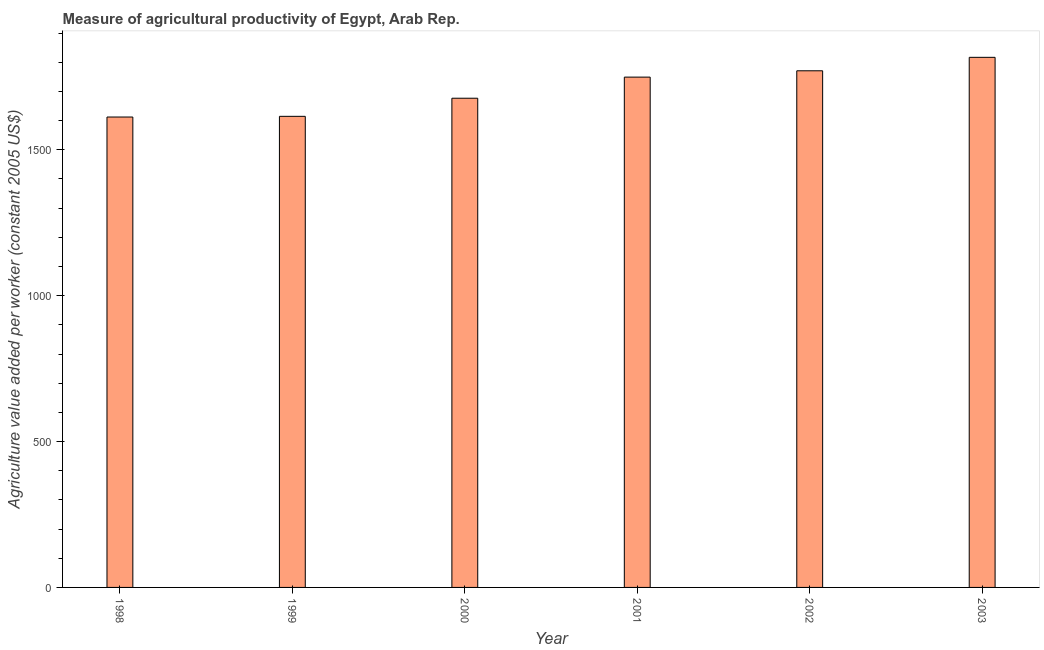What is the title of the graph?
Provide a short and direct response. Measure of agricultural productivity of Egypt, Arab Rep. What is the label or title of the X-axis?
Provide a succinct answer. Year. What is the label or title of the Y-axis?
Ensure brevity in your answer.  Agriculture value added per worker (constant 2005 US$). What is the agriculture value added per worker in 2000?
Make the answer very short. 1676.86. Across all years, what is the maximum agriculture value added per worker?
Your answer should be very brief. 1817.06. Across all years, what is the minimum agriculture value added per worker?
Your answer should be very brief. 1612.44. In which year was the agriculture value added per worker minimum?
Provide a short and direct response. 1998. What is the sum of the agriculture value added per worker?
Make the answer very short. 1.02e+04. What is the difference between the agriculture value added per worker in 2000 and 2002?
Provide a short and direct response. -94.06. What is the average agriculture value added per worker per year?
Your answer should be very brief. 1706.89. What is the median agriculture value added per worker?
Give a very brief answer. 1713.05. In how many years, is the agriculture value added per worker greater than 200 US$?
Provide a succinct answer. 6. Is the agriculture value added per worker in 2000 less than that in 2002?
Provide a succinct answer. Yes. Is the difference between the agriculture value added per worker in 1999 and 2002 greater than the difference between any two years?
Offer a terse response. No. What is the difference between the highest and the second highest agriculture value added per worker?
Your response must be concise. 46.13. Is the sum of the agriculture value added per worker in 1998 and 2001 greater than the maximum agriculture value added per worker across all years?
Keep it short and to the point. Yes. What is the difference between the highest and the lowest agriculture value added per worker?
Your answer should be compact. 204.62. In how many years, is the agriculture value added per worker greater than the average agriculture value added per worker taken over all years?
Your answer should be compact. 3. How many bars are there?
Your response must be concise. 6. What is the difference between two consecutive major ticks on the Y-axis?
Give a very brief answer. 500. Are the values on the major ticks of Y-axis written in scientific E-notation?
Offer a terse response. No. What is the Agriculture value added per worker (constant 2005 US$) of 1998?
Give a very brief answer. 1612.44. What is the Agriculture value added per worker (constant 2005 US$) of 1999?
Your answer should be very brief. 1614.8. What is the Agriculture value added per worker (constant 2005 US$) of 2000?
Provide a short and direct response. 1676.86. What is the Agriculture value added per worker (constant 2005 US$) of 2001?
Offer a very short reply. 1749.25. What is the Agriculture value added per worker (constant 2005 US$) in 2002?
Offer a very short reply. 1770.92. What is the Agriculture value added per worker (constant 2005 US$) of 2003?
Offer a very short reply. 1817.06. What is the difference between the Agriculture value added per worker (constant 2005 US$) in 1998 and 1999?
Ensure brevity in your answer.  -2.37. What is the difference between the Agriculture value added per worker (constant 2005 US$) in 1998 and 2000?
Your answer should be very brief. -64.42. What is the difference between the Agriculture value added per worker (constant 2005 US$) in 1998 and 2001?
Offer a very short reply. -136.81. What is the difference between the Agriculture value added per worker (constant 2005 US$) in 1998 and 2002?
Provide a short and direct response. -158.49. What is the difference between the Agriculture value added per worker (constant 2005 US$) in 1998 and 2003?
Your answer should be very brief. -204.62. What is the difference between the Agriculture value added per worker (constant 2005 US$) in 1999 and 2000?
Provide a succinct answer. -62.05. What is the difference between the Agriculture value added per worker (constant 2005 US$) in 1999 and 2001?
Offer a very short reply. -134.44. What is the difference between the Agriculture value added per worker (constant 2005 US$) in 1999 and 2002?
Offer a very short reply. -156.12. What is the difference between the Agriculture value added per worker (constant 2005 US$) in 1999 and 2003?
Ensure brevity in your answer.  -202.25. What is the difference between the Agriculture value added per worker (constant 2005 US$) in 2000 and 2001?
Provide a short and direct response. -72.39. What is the difference between the Agriculture value added per worker (constant 2005 US$) in 2000 and 2002?
Provide a succinct answer. -94.06. What is the difference between the Agriculture value added per worker (constant 2005 US$) in 2000 and 2003?
Your response must be concise. -140.2. What is the difference between the Agriculture value added per worker (constant 2005 US$) in 2001 and 2002?
Your answer should be very brief. -21.67. What is the difference between the Agriculture value added per worker (constant 2005 US$) in 2001 and 2003?
Offer a very short reply. -67.81. What is the difference between the Agriculture value added per worker (constant 2005 US$) in 2002 and 2003?
Your response must be concise. -46.13. What is the ratio of the Agriculture value added per worker (constant 2005 US$) in 1998 to that in 2000?
Make the answer very short. 0.96. What is the ratio of the Agriculture value added per worker (constant 2005 US$) in 1998 to that in 2001?
Give a very brief answer. 0.92. What is the ratio of the Agriculture value added per worker (constant 2005 US$) in 1998 to that in 2002?
Make the answer very short. 0.91. What is the ratio of the Agriculture value added per worker (constant 2005 US$) in 1998 to that in 2003?
Give a very brief answer. 0.89. What is the ratio of the Agriculture value added per worker (constant 2005 US$) in 1999 to that in 2000?
Your response must be concise. 0.96. What is the ratio of the Agriculture value added per worker (constant 2005 US$) in 1999 to that in 2001?
Ensure brevity in your answer.  0.92. What is the ratio of the Agriculture value added per worker (constant 2005 US$) in 1999 to that in 2002?
Provide a succinct answer. 0.91. What is the ratio of the Agriculture value added per worker (constant 2005 US$) in 1999 to that in 2003?
Ensure brevity in your answer.  0.89. What is the ratio of the Agriculture value added per worker (constant 2005 US$) in 2000 to that in 2002?
Make the answer very short. 0.95. What is the ratio of the Agriculture value added per worker (constant 2005 US$) in 2000 to that in 2003?
Your response must be concise. 0.92. What is the ratio of the Agriculture value added per worker (constant 2005 US$) in 2001 to that in 2002?
Provide a short and direct response. 0.99. What is the ratio of the Agriculture value added per worker (constant 2005 US$) in 2002 to that in 2003?
Provide a short and direct response. 0.97. 